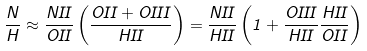Convert formula to latex. <formula><loc_0><loc_0><loc_500><loc_500>\frac { N } { H } \approx \frac { N I I } { O I I } \left ( \frac { O I I + O I I I } { H I I } \right ) = \frac { N I I } { H I I } \left ( 1 + \frac { O I I I } { H I I } \frac { H I I } { O I I } \right )</formula> 